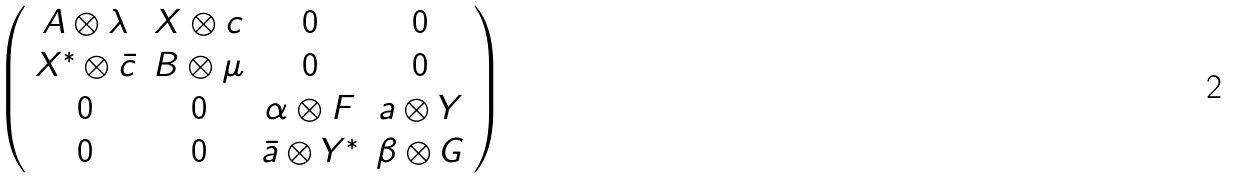Convert formula to latex. <formula><loc_0><loc_0><loc_500><loc_500>\left ( \begin{array} { c c c c } A \otimes \lambda & X \otimes c & 0 & 0 \\ X ^ { \ast } \otimes \bar { c } & B \otimes \mu & 0 & 0 \\ 0 & 0 & \alpha \otimes F & a \otimes Y \\ 0 & 0 & \bar { a } \otimes Y ^ { * } & \beta \otimes G \end{array} \right )</formula> 